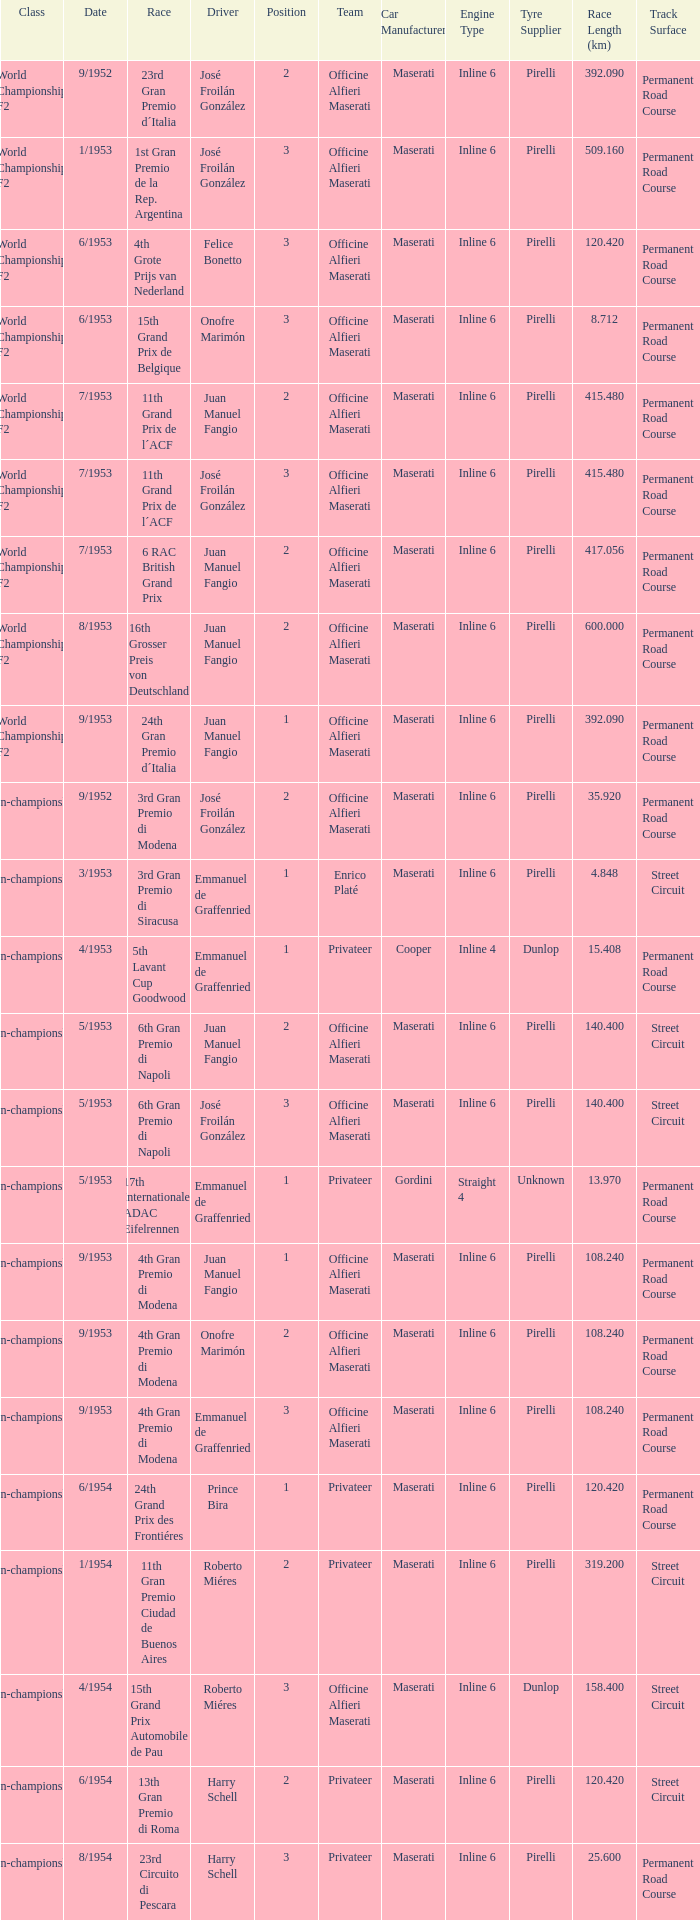What class has the date of 8/1954? Non-championship F1. 